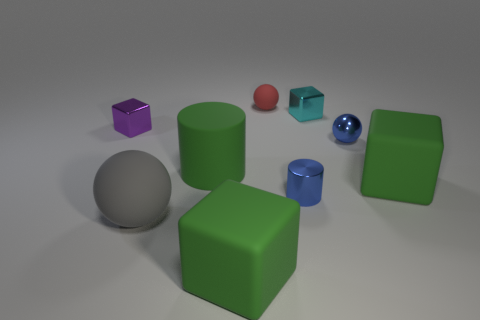Subtract 2 blocks. How many blocks are left? 2 Subtract all blue cubes. Subtract all blue spheres. How many cubes are left? 4 Add 1 small red metal balls. How many objects exist? 10 Subtract all cubes. How many objects are left? 5 Add 4 tiny things. How many tiny things exist? 9 Subtract 0 red cubes. How many objects are left? 9 Subtract all tiny red spheres. Subtract all cyan shiny things. How many objects are left? 7 Add 5 tiny red rubber objects. How many tiny red rubber objects are left? 6 